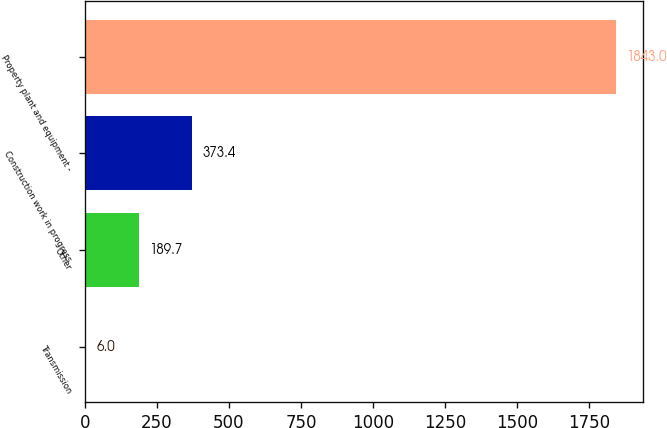<chart> <loc_0><loc_0><loc_500><loc_500><bar_chart><fcel>Transmission<fcel>Other<fcel>Construction work in progress<fcel>Property plant and equipment -<nl><fcel>6<fcel>189.7<fcel>373.4<fcel>1843<nl></chart> 